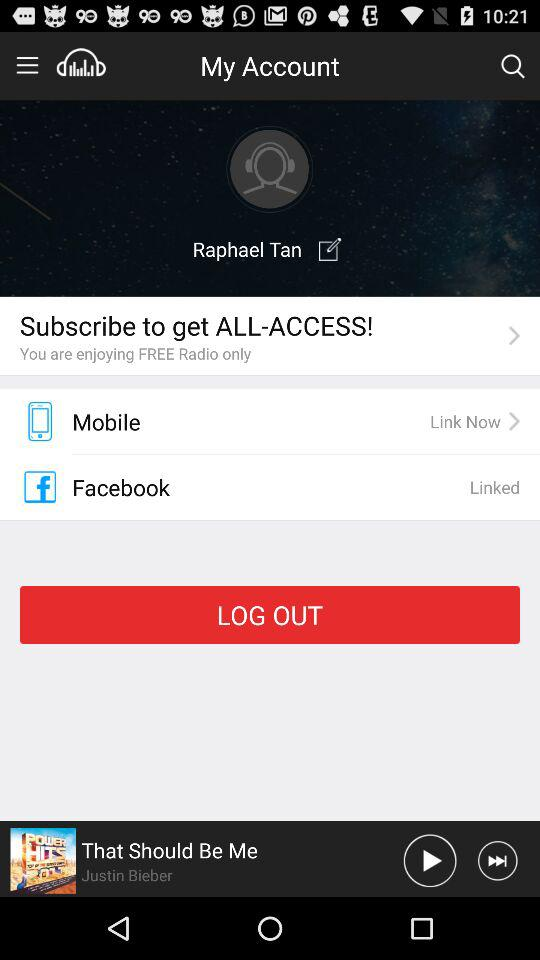What is the user name? The user name is Raphael Tan. 